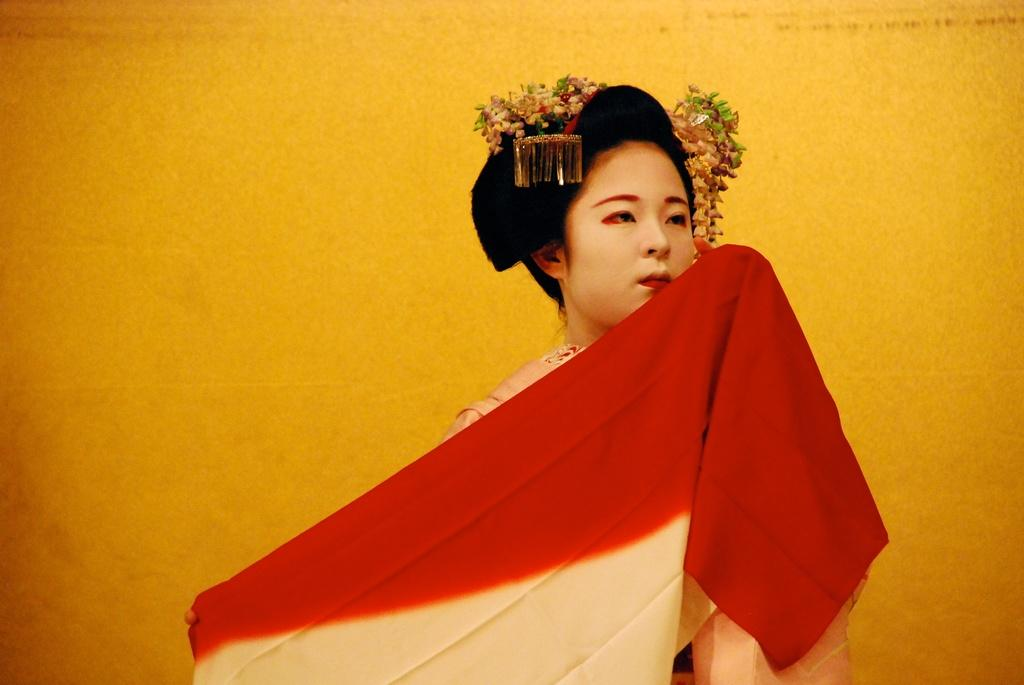Who is the main subject in the image? There is a woman in the image. What is the woman holding in her hands? The woman is holding a red cloth in her hands. Are there any other objects visible on the woman? Yes, there are other objects on the woman's head. What is the color of the background in the image? The background of the image is in yellow color. What type of loaf is the woman carrying on her neck in the image? There is no loaf present in the image, and the woman is not carrying anything on her neck. 